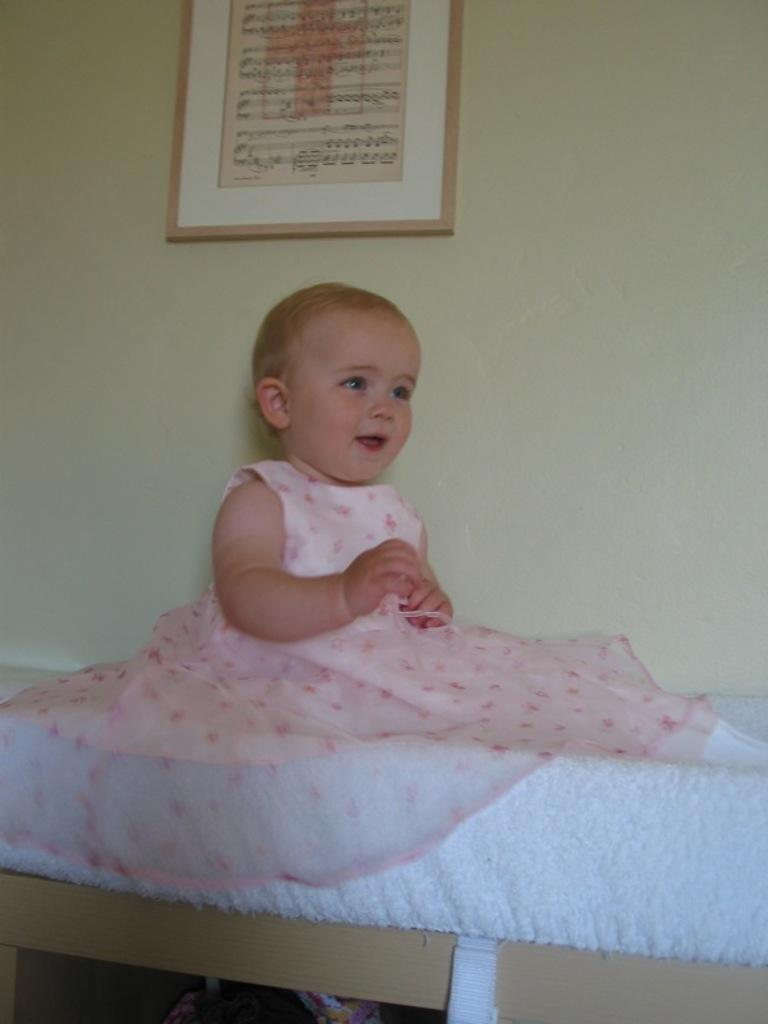What is the toddler doing in the image? The toddler is sitting on the bed. What can be seen on the wall beside the bed? There is a photo frame on the wall beside the bed. What is located beneath the bed? There are objects beneath the bed. Is the toddler involved in a fight with the pet in the image? There is no pet present in the image, so the toddler is not involved in a fight with a pet. 